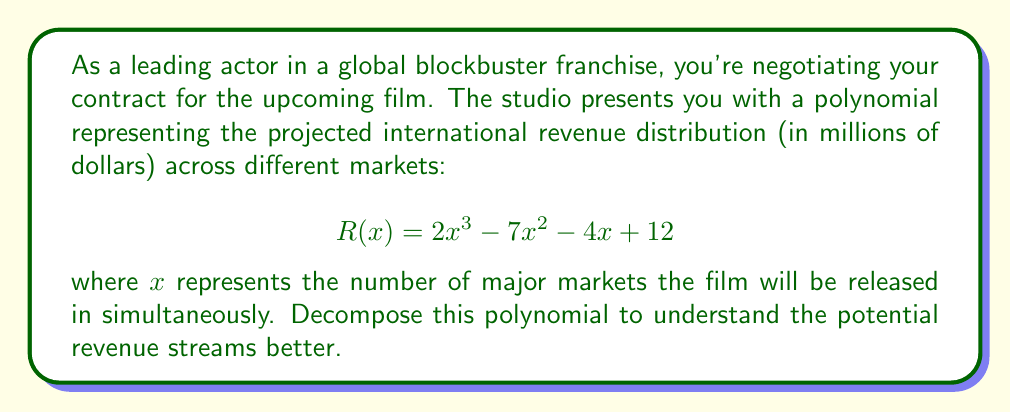Teach me how to tackle this problem. To decompose the polynomial $R(x) = 2x^3 - 7x^2 - 4x + 12$, we'll follow these steps:

1) First, let's check if there are any common factors:
   There are no common factors for all terms, so we proceed to the next step.

2) We'll use the rational root theorem to find potential roots. The possible rational roots are the factors of the constant term (12): ±1, ±2, ±3, ±4, ±6, ±12

3) Testing these values, we find that x = 2 is a root. So (x - 2) is a factor.

4) Divide the polynomial by (x - 2):

   $$\frac{2x^3 - 7x^2 - 4x + 12}{x - 2} = 2x^2 + 3x - 6$$

5) Now we have: $R(x) = (x - 2)(2x^2 + 3x - 6)$

6) The quadratic factor $2x^2 + 3x - 6$ can be further factored:
   
   $2x^2 + 3x - 6 = (2x - 3)(x + 2)$

7) Therefore, the fully factored polynomial is:

   $$R(x) = (x - 2)(2x - 3)(x + 2)$$

This decomposition reveals three critical points in the revenue distribution:
- When x = 2 (release in 2 major markets)
- When x = 1.5 (release in 1.5 major markets, which could represent a full release in one market and a partial release in another)
- When x = -2 (not practically meaningful in this context, but mathematically important)
Answer: $$R(x) = (x - 2)(2x - 3)(x + 2)$$ 